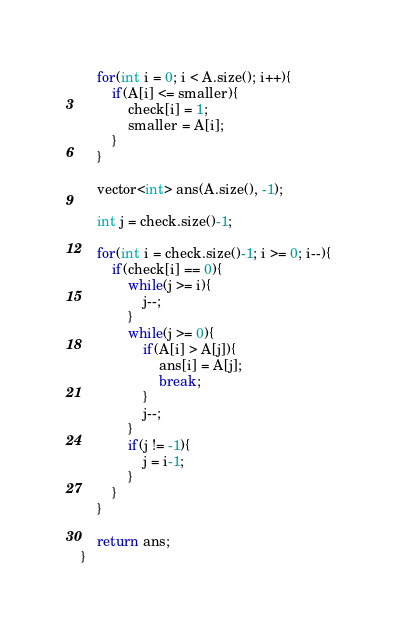Convert code to text. <code><loc_0><loc_0><loc_500><loc_500><_C++_>    for(int i = 0; i < A.size(); i++){
        if(A[i] <= smaller){
            check[i] = 1;
            smaller = A[i];
        }
    }
    
    vector<int> ans(A.size(), -1);
    
    int j = check.size()-1;
    
    for(int i = check.size()-1; i >= 0; i--){
        if(check[i] == 0){
            while(j >= i){
                j--;
            }
            while(j >= 0){
                if(A[i] > A[j]){
                    ans[i] = A[j];
                    break;
                }
                j--;
            }
            if(j != -1){
                j = i-1;
            }
        }
    }
    
    return ans;
}
</code> 